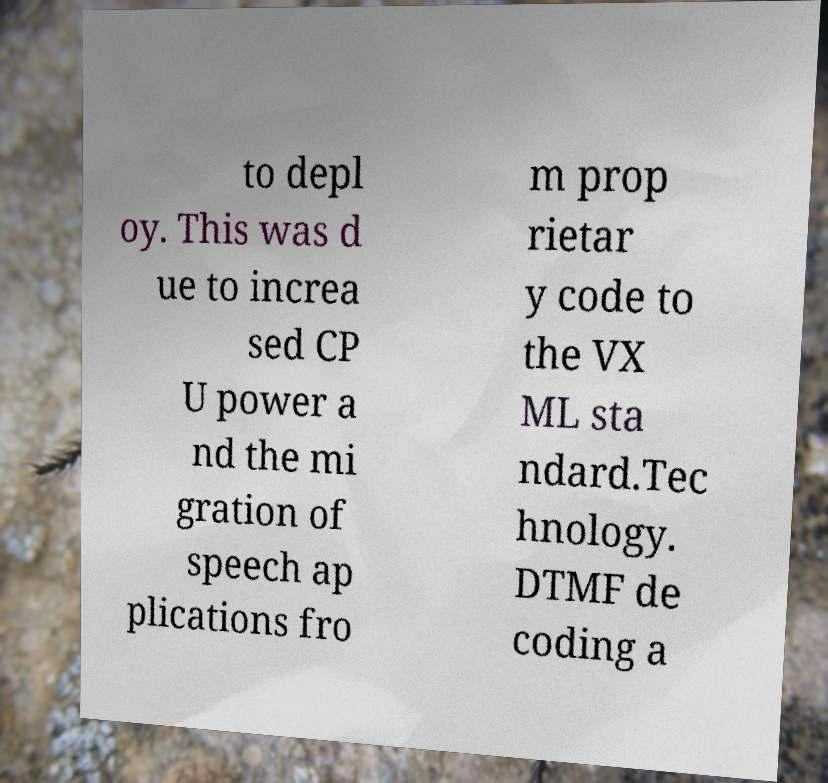Can you accurately transcribe the text from the provided image for me? to depl oy. This was d ue to increa sed CP U power a nd the mi gration of speech ap plications fro m prop rietar y code to the VX ML sta ndard.Tec hnology. DTMF de coding a 